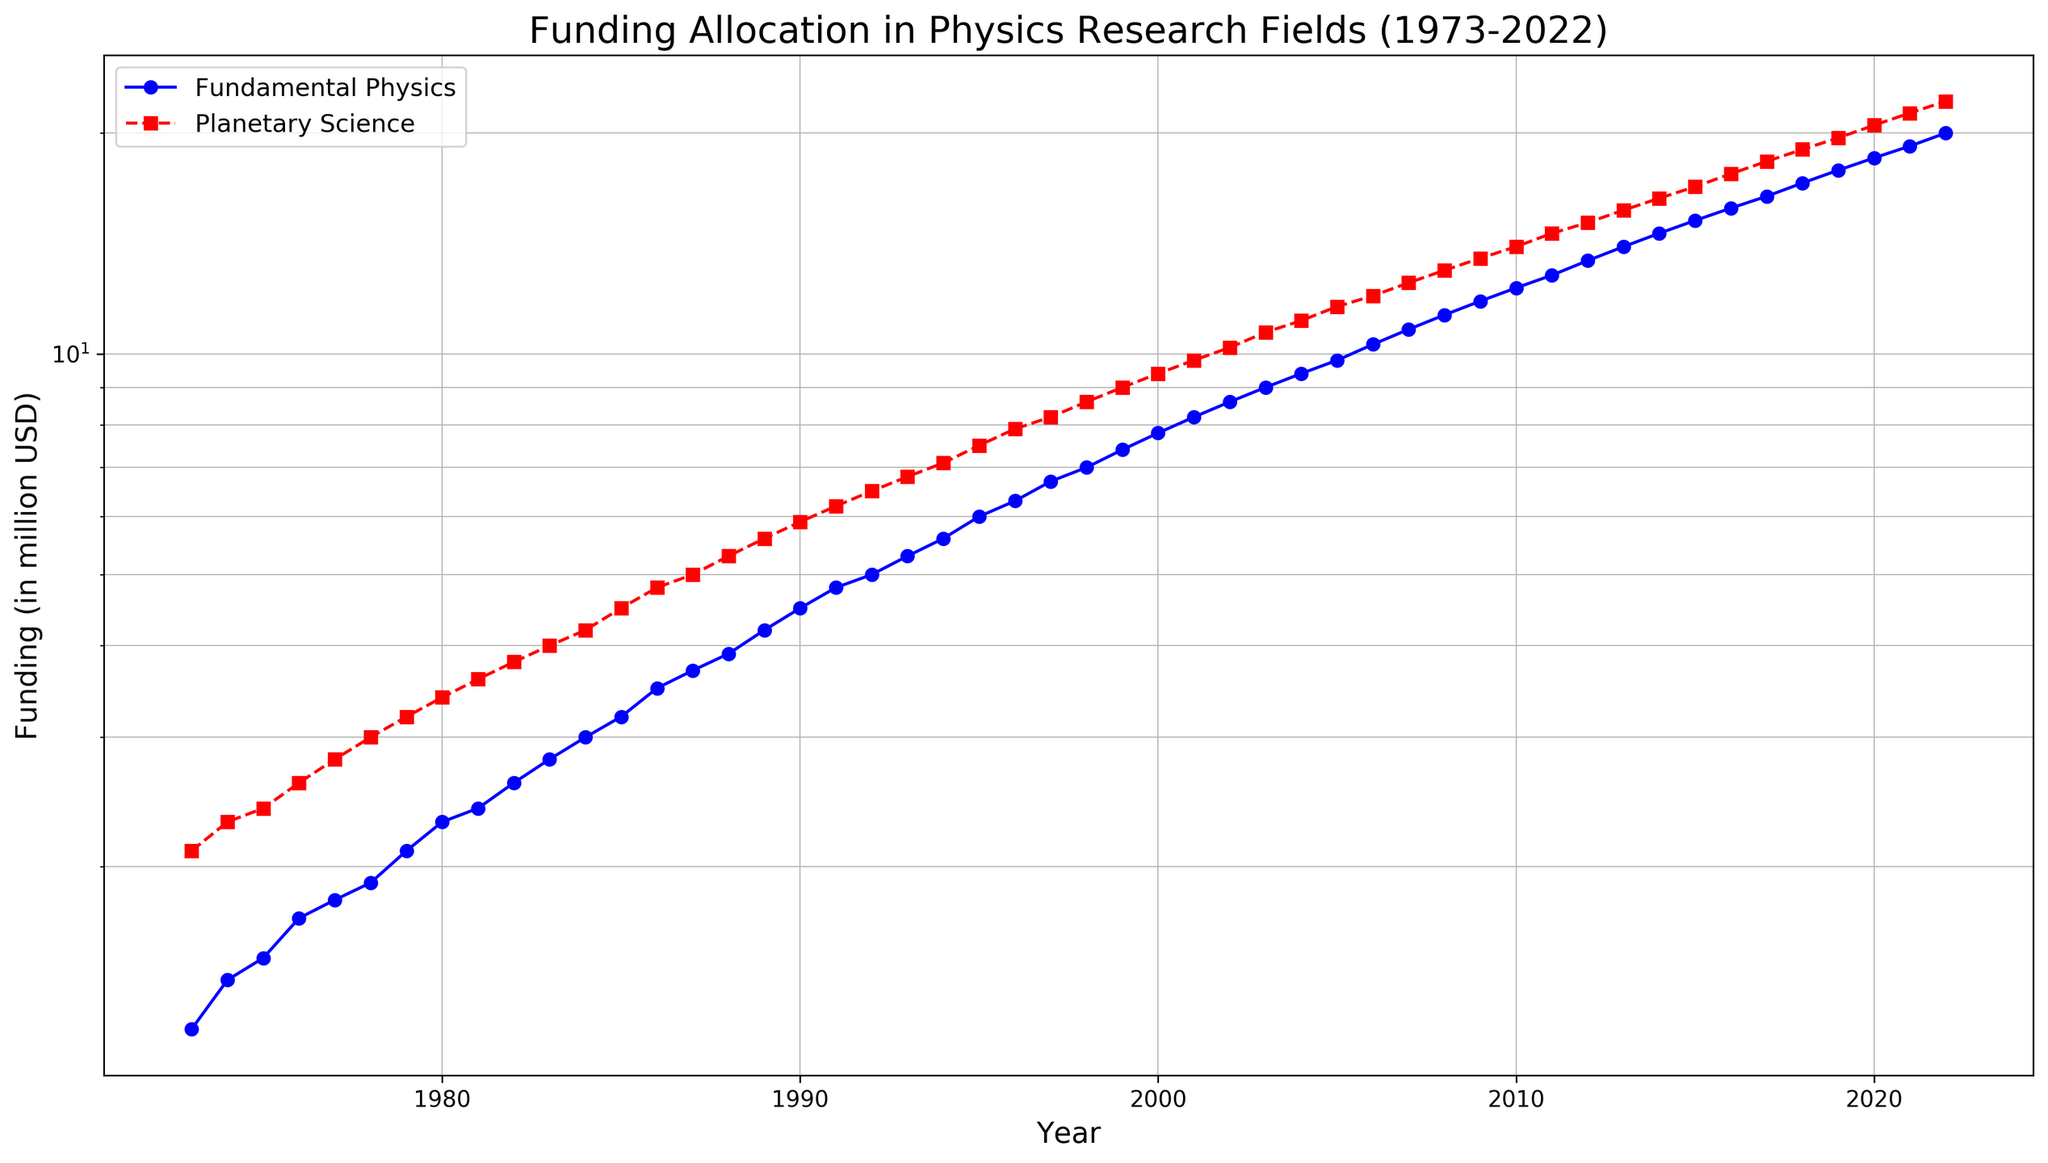What is the general trend in the funding for Fundamental Physics over the 50-year period? The plot shows an increasing trend for Fundamental Physics funding from 1973 to 2022. Initially, the funding is around 1.2 million USD in 1973, and it continuously increases to around 20 million USD by 2022.
Answer: Increasing How can you describe the difference in growth trends between Fundamental Physics and Planetary Science funding? Both fields show an increasing trend, but Fundamental Physics funding grows at a slightly faster rate than Planetary Science funding over time. This can be observed as the gap between the two funding lines narrows with each passing year, especially after the early 1980s.
Answer: Fundamental Physics grows faster In which year did the funding of Fundamental Physics reach 10 million USD? According to the plot, the funding of Fundamental Physics reaches around 10 million USD in 2006.
Answer: 2006 What is the funding difference between Fundamental Physics and Planetary Science in 1990? In 1990, the funding for Fundamental Physics is about 4.5 million USD and for Planetary Science is about 5.9 million USD. The difference is calculated as 5.9 - 4.5 = 1.4 million USD.
Answer: 1.4 million USD During which decade did Fundamental Physics funding surpass Planetary Science funding? Observing the plot, Fundamental Physics funding surpasses Planetary Science funding in the 1980s. Specifically, around 1986-1987.
Answer: 1980s Calculate the average annual increase in funding for Fundamental Physics between 1973 and 2022. To find the average annual increase, we take the funding in 2022 (20 million USD) subtract the funding in 1973 (1.2 million USD) and divide by the number of years (2022-1973 = 49 years). The average annual increase is (20 - 1.2) / 49 ≈ 0.38 million USD/year.
Answer: 0.38 million USD/year Compare the visual styles of the lines representing Fundamental Physics and Planetary Science funding. The line representing Fundamental Physics funding is blue with circular markers and a solid line style. The line representing Planetary Science funding is red with square markers and a dashed line style.
Answer: Fundamental Physics: solid blue with circles; Planetary Science: dashed red with squares In which year did both funding lines display their steepest slope, indicating the fastest growth rates within the five decades? By analyzing the plot visually, the steepest slope for both funding lines appears between 2010 and 2012. The funding for both fields shows a sharp increase during this period.
Answer: 2010-2012 What is the difference in funding between Fundamental Physics and Planetary Science in 2022? In 2022, the funding for Fundamental Physics is about 20 million USD, and for Planetary Science is about 22.1 million USD. The difference is calculated as 22.1 - 20 = 2.1 million USD.
Answer: 2.1 million USD Using the log scale applied, describe the relative growth rate of the two fields before and after the year 2000. On a log scale, constant growth rates appear as straight lines. Both fields show a relatively steady growth rate before 2000. After 2000, the slopes become steeper, indicating an accelerated growth rate for both fields. However, the slope for Fundamental Physics becomes relatively steeper compared to Planetary Science, showing higher relative growth post-2000.
Answer: Higher relative growth for Fundamental Physics post-2000 